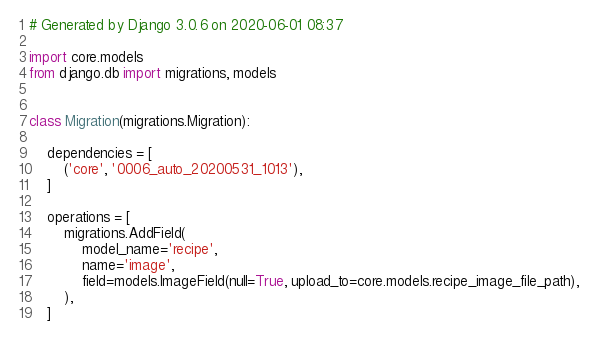<code> <loc_0><loc_0><loc_500><loc_500><_Python_># Generated by Django 3.0.6 on 2020-06-01 08:37

import core.models
from django.db import migrations, models


class Migration(migrations.Migration):

    dependencies = [
        ('core', '0006_auto_20200531_1013'),
    ]

    operations = [
        migrations.AddField(
            model_name='recipe',
            name='image',
            field=models.ImageField(null=True, upload_to=core.models.recipe_image_file_path),
        ),
    ]
</code> 